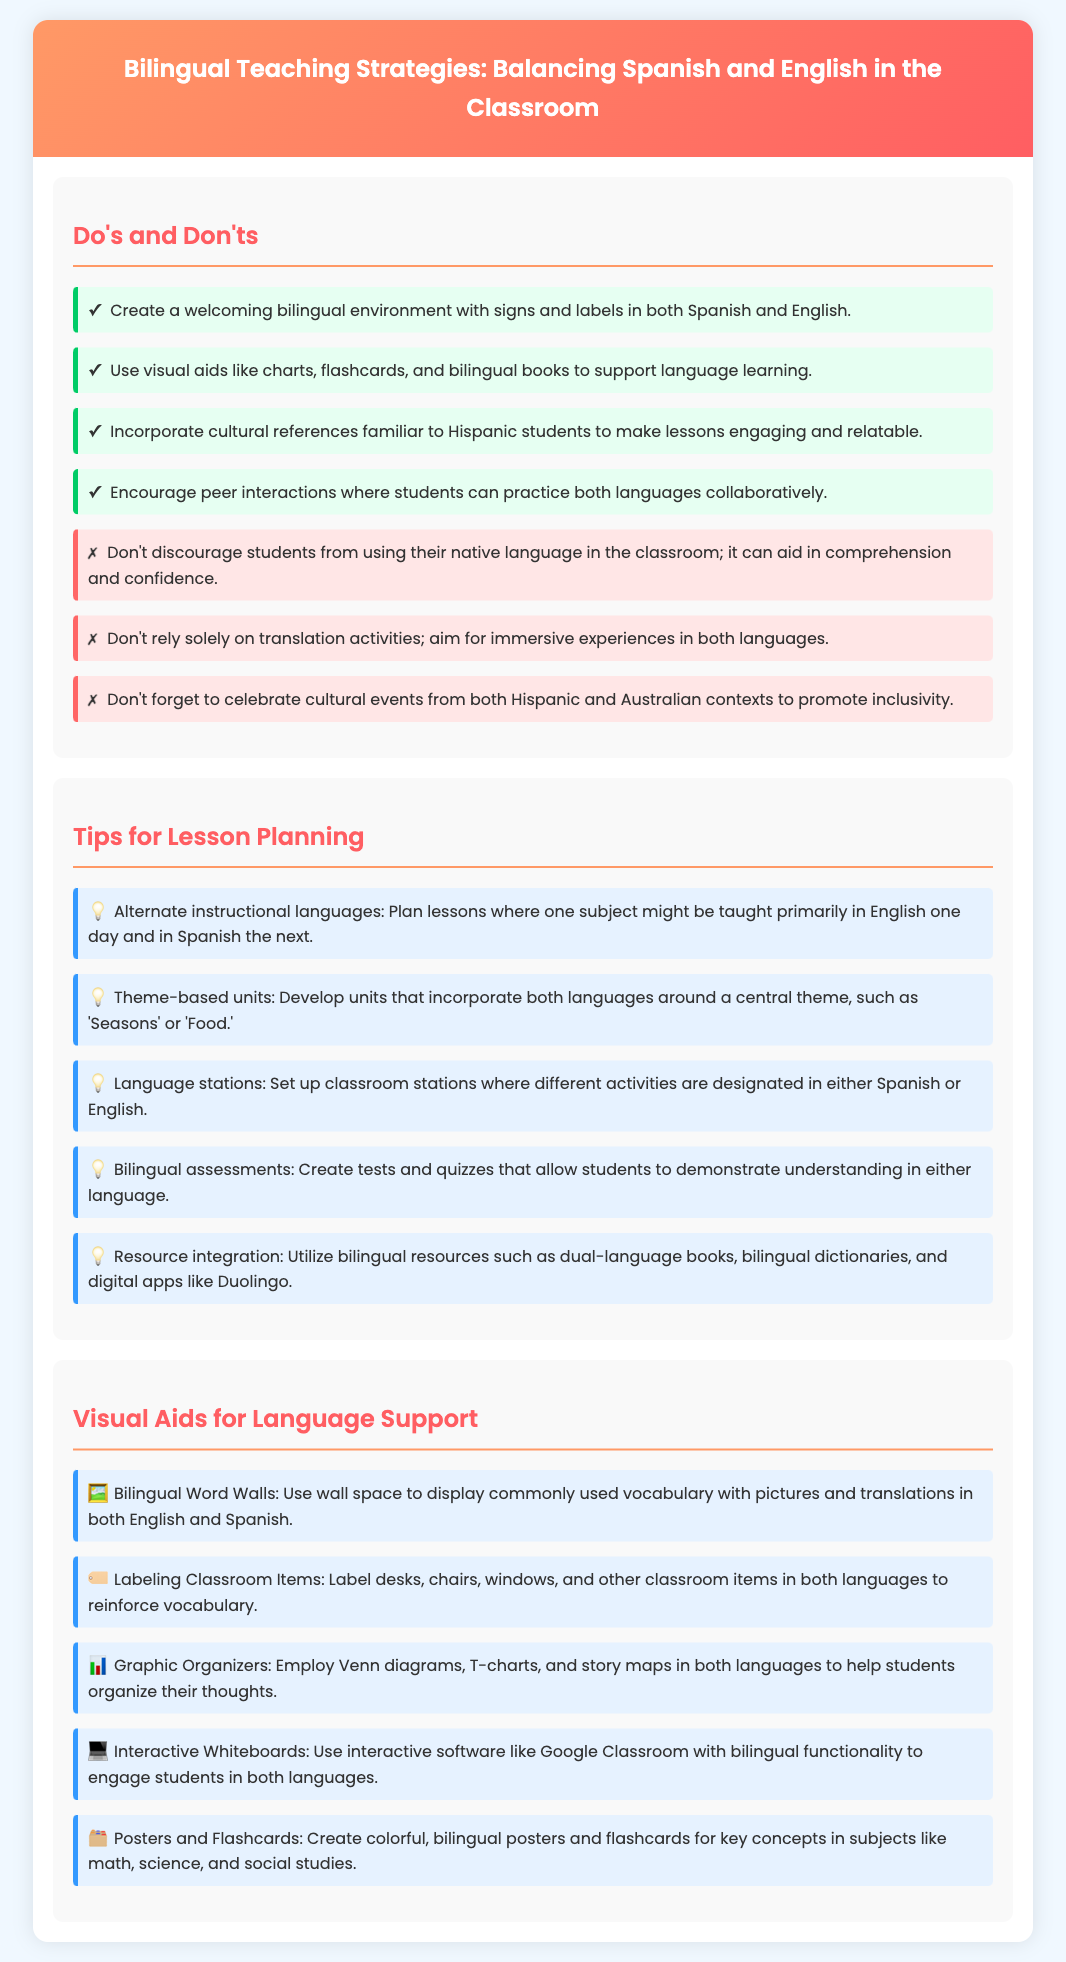What are the main colors used in the header? The header features a linear gradient with colors that go from #FF9966 to #FF5E62.
Answer: Orange and pink How many do's are listed in the document? There are four specific do's provided in the "Do's and Don'ts" section.
Answer: Four What is one cultural aspect to include in lessons? The document suggests incorporating cultural references familiar to Hispanic students.
Answer: Cultural references What type of assessments are recommended? The tips suggest using bilingual assessments to aid language understanding.
Answer: Bilingual assessments What visual aid is used to display vocabulary? The infographic recommends implementing bilingual word walls for vocabulary support.
Answer: Bilingual Word Walls What is a key method for lesson planning? The document mentions alternating instructional languages for different lessons.
Answer: Alternate instructional languages How many language stations should be set up? The document doesn’t specify a number but suggests setting up multiple language stations.
Answer: Multiple What interactive tool is mentioned for bilingual engagement? The document recommends using interactive whiteboards with bilingual functionality.
Answer: Interactive Whiteboards What should classroom items be labeled with? The items in the classroom should be labeled in both Spanish and English.
Answer: Both languages 